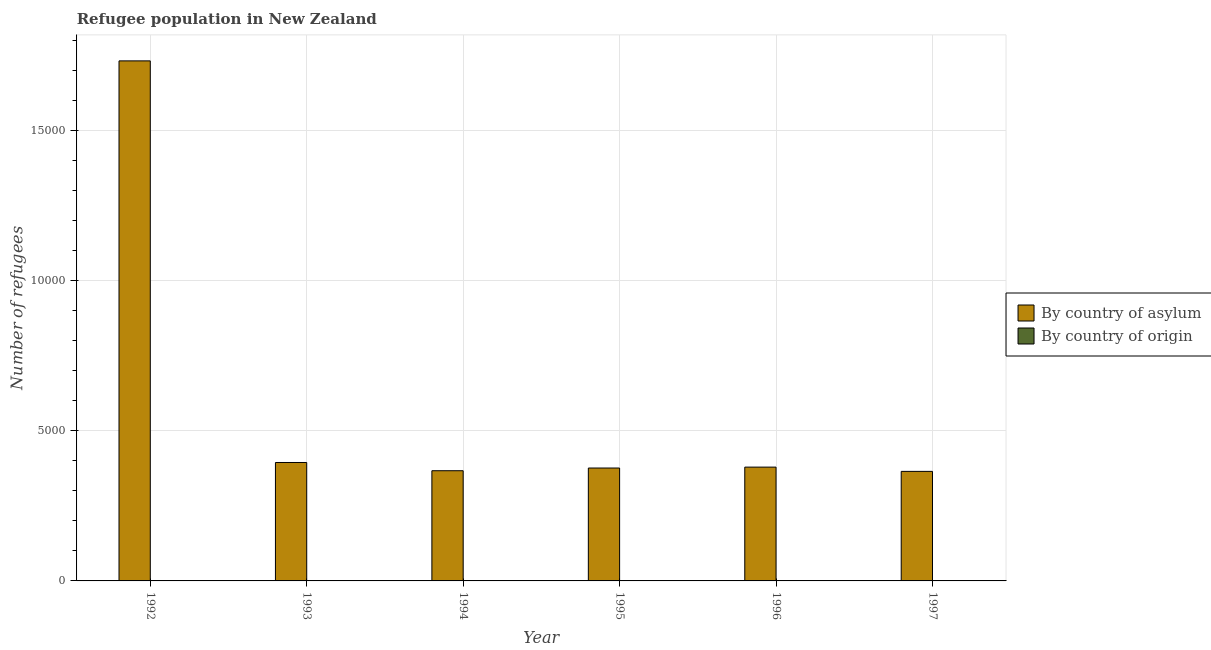How many different coloured bars are there?
Give a very brief answer. 2. How many groups of bars are there?
Your answer should be compact. 6. How many bars are there on the 1st tick from the left?
Keep it short and to the point. 2. What is the label of the 4th group of bars from the left?
Your response must be concise. 1995. In how many cases, is the number of bars for a given year not equal to the number of legend labels?
Offer a terse response. 0. What is the number of refugees by country of asylum in 1997?
Your answer should be very brief. 3646. Across all years, what is the maximum number of refugees by country of asylum?
Your answer should be compact. 1.73e+04. Across all years, what is the minimum number of refugees by country of asylum?
Your answer should be very brief. 3646. In which year was the number of refugees by country of origin maximum?
Your answer should be very brief. 1995. In which year was the number of refugees by country of origin minimum?
Give a very brief answer. 1992. What is the total number of refugees by country of origin in the graph?
Provide a succinct answer. 48. What is the difference between the number of refugees by country of asylum in 1993 and that in 1997?
Keep it short and to the point. 296. What is the difference between the number of refugees by country of origin in 1995 and the number of refugees by country of asylum in 1993?
Offer a terse response. 9. What is the average number of refugees by country of asylum per year?
Ensure brevity in your answer.  6018.67. What is the ratio of the number of refugees by country of asylum in 1992 to that in 1994?
Your answer should be very brief. 4.72. Is the number of refugees by country of origin in 1994 less than that in 1995?
Provide a short and direct response. Yes. What is the difference between the highest and the second highest number of refugees by country of asylum?
Ensure brevity in your answer.  1.34e+04. What is the difference between the highest and the lowest number of refugees by country of asylum?
Ensure brevity in your answer.  1.37e+04. In how many years, is the number of refugees by country of origin greater than the average number of refugees by country of origin taken over all years?
Your answer should be very brief. 3. What does the 1st bar from the left in 1993 represents?
Your answer should be compact. By country of asylum. What does the 1st bar from the right in 1992 represents?
Your response must be concise. By country of origin. Are the values on the major ticks of Y-axis written in scientific E-notation?
Give a very brief answer. No. How many legend labels are there?
Provide a short and direct response. 2. What is the title of the graph?
Offer a very short reply. Refugee population in New Zealand. Does "Education" appear as one of the legend labels in the graph?
Offer a terse response. No. What is the label or title of the Y-axis?
Ensure brevity in your answer.  Number of refugees. What is the Number of refugees of By country of asylum in 1992?
Ensure brevity in your answer.  1.73e+04. What is the Number of refugees of By country of origin in 1992?
Ensure brevity in your answer.  3. What is the Number of refugees of By country of asylum in 1993?
Give a very brief answer. 3942. What is the Number of refugees of By country of origin in 1993?
Provide a succinct answer. 4. What is the Number of refugees of By country of asylum in 1994?
Give a very brief answer. 3668. What is the Number of refugees in By country of origin in 1994?
Your response must be concise. 8. What is the Number of refugees of By country of asylum in 1995?
Make the answer very short. 3758. What is the Number of refugees of By country of origin in 1995?
Your response must be concise. 13. What is the Number of refugees in By country of asylum in 1996?
Give a very brief answer. 3788. What is the Number of refugees of By country of asylum in 1997?
Your answer should be compact. 3646. Across all years, what is the maximum Number of refugees of By country of asylum?
Offer a terse response. 1.73e+04. Across all years, what is the minimum Number of refugees of By country of asylum?
Your answer should be very brief. 3646. Across all years, what is the minimum Number of refugees of By country of origin?
Your response must be concise. 3. What is the total Number of refugees in By country of asylum in the graph?
Give a very brief answer. 3.61e+04. What is the difference between the Number of refugees of By country of asylum in 1992 and that in 1993?
Your answer should be very brief. 1.34e+04. What is the difference between the Number of refugees of By country of asylum in 1992 and that in 1994?
Give a very brief answer. 1.36e+04. What is the difference between the Number of refugees in By country of asylum in 1992 and that in 1995?
Ensure brevity in your answer.  1.36e+04. What is the difference between the Number of refugees of By country of asylum in 1992 and that in 1996?
Your answer should be very brief. 1.35e+04. What is the difference between the Number of refugees in By country of asylum in 1992 and that in 1997?
Your response must be concise. 1.37e+04. What is the difference between the Number of refugees in By country of origin in 1992 and that in 1997?
Provide a short and direct response. -7. What is the difference between the Number of refugees of By country of asylum in 1993 and that in 1994?
Provide a succinct answer. 274. What is the difference between the Number of refugees in By country of origin in 1993 and that in 1994?
Your answer should be compact. -4. What is the difference between the Number of refugees of By country of asylum in 1993 and that in 1995?
Give a very brief answer. 184. What is the difference between the Number of refugees of By country of origin in 1993 and that in 1995?
Provide a succinct answer. -9. What is the difference between the Number of refugees in By country of asylum in 1993 and that in 1996?
Your answer should be compact. 154. What is the difference between the Number of refugees of By country of origin in 1993 and that in 1996?
Provide a short and direct response. -6. What is the difference between the Number of refugees in By country of asylum in 1993 and that in 1997?
Provide a succinct answer. 296. What is the difference between the Number of refugees of By country of origin in 1993 and that in 1997?
Your response must be concise. -6. What is the difference between the Number of refugees in By country of asylum in 1994 and that in 1995?
Provide a short and direct response. -90. What is the difference between the Number of refugees of By country of origin in 1994 and that in 1995?
Your answer should be compact. -5. What is the difference between the Number of refugees of By country of asylum in 1994 and that in 1996?
Your answer should be very brief. -120. What is the difference between the Number of refugees of By country of origin in 1994 and that in 1996?
Your response must be concise. -2. What is the difference between the Number of refugees in By country of origin in 1994 and that in 1997?
Offer a terse response. -2. What is the difference between the Number of refugees in By country of asylum in 1995 and that in 1996?
Ensure brevity in your answer.  -30. What is the difference between the Number of refugees in By country of asylum in 1995 and that in 1997?
Offer a very short reply. 112. What is the difference between the Number of refugees of By country of origin in 1995 and that in 1997?
Keep it short and to the point. 3. What is the difference between the Number of refugees of By country of asylum in 1996 and that in 1997?
Provide a succinct answer. 142. What is the difference between the Number of refugees of By country of asylum in 1992 and the Number of refugees of By country of origin in 1993?
Provide a short and direct response. 1.73e+04. What is the difference between the Number of refugees in By country of asylum in 1992 and the Number of refugees in By country of origin in 1994?
Provide a succinct answer. 1.73e+04. What is the difference between the Number of refugees of By country of asylum in 1992 and the Number of refugees of By country of origin in 1995?
Offer a terse response. 1.73e+04. What is the difference between the Number of refugees in By country of asylum in 1992 and the Number of refugees in By country of origin in 1996?
Make the answer very short. 1.73e+04. What is the difference between the Number of refugees of By country of asylum in 1992 and the Number of refugees of By country of origin in 1997?
Your answer should be very brief. 1.73e+04. What is the difference between the Number of refugees of By country of asylum in 1993 and the Number of refugees of By country of origin in 1994?
Provide a short and direct response. 3934. What is the difference between the Number of refugees of By country of asylum in 1993 and the Number of refugees of By country of origin in 1995?
Provide a short and direct response. 3929. What is the difference between the Number of refugees in By country of asylum in 1993 and the Number of refugees in By country of origin in 1996?
Offer a very short reply. 3932. What is the difference between the Number of refugees in By country of asylum in 1993 and the Number of refugees in By country of origin in 1997?
Ensure brevity in your answer.  3932. What is the difference between the Number of refugees of By country of asylum in 1994 and the Number of refugees of By country of origin in 1995?
Offer a very short reply. 3655. What is the difference between the Number of refugees of By country of asylum in 1994 and the Number of refugees of By country of origin in 1996?
Ensure brevity in your answer.  3658. What is the difference between the Number of refugees in By country of asylum in 1994 and the Number of refugees in By country of origin in 1997?
Provide a short and direct response. 3658. What is the difference between the Number of refugees in By country of asylum in 1995 and the Number of refugees in By country of origin in 1996?
Keep it short and to the point. 3748. What is the difference between the Number of refugees in By country of asylum in 1995 and the Number of refugees in By country of origin in 1997?
Offer a terse response. 3748. What is the difference between the Number of refugees in By country of asylum in 1996 and the Number of refugees in By country of origin in 1997?
Provide a short and direct response. 3778. What is the average Number of refugees of By country of asylum per year?
Keep it short and to the point. 6018.67. What is the average Number of refugees in By country of origin per year?
Offer a terse response. 8. In the year 1992, what is the difference between the Number of refugees in By country of asylum and Number of refugees in By country of origin?
Offer a terse response. 1.73e+04. In the year 1993, what is the difference between the Number of refugees in By country of asylum and Number of refugees in By country of origin?
Provide a succinct answer. 3938. In the year 1994, what is the difference between the Number of refugees in By country of asylum and Number of refugees in By country of origin?
Make the answer very short. 3660. In the year 1995, what is the difference between the Number of refugees in By country of asylum and Number of refugees in By country of origin?
Make the answer very short. 3745. In the year 1996, what is the difference between the Number of refugees in By country of asylum and Number of refugees in By country of origin?
Your answer should be compact. 3778. In the year 1997, what is the difference between the Number of refugees of By country of asylum and Number of refugees of By country of origin?
Give a very brief answer. 3636. What is the ratio of the Number of refugees of By country of asylum in 1992 to that in 1993?
Your answer should be very brief. 4.39. What is the ratio of the Number of refugees of By country of origin in 1992 to that in 1993?
Make the answer very short. 0.75. What is the ratio of the Number of refugees of By country of asylum in 1992 to that in 1994?
Provide a succinct answer. 4.72. What is the ratio of the Number of refugees in By country of origin in 1992 to that in 1994?
Give a very brief answer. 0.38. What is the ratio of the Number of refugees of By country of asylum in 1992 to that in 1995?
Your response must be concise. 4.61. What is the ratio of the Number of refugees of By country of origin in 1992 to that in 1995?
Your response must be concise. 0.23. What is the ratio of the Number of refugees of By country of asylum in 1992 to that in 1996?
Give a very brief answer. 4.57. What is the ratio of the Number of refugees in By country of asylum in 1992 to that in 1997?
Provide a short and direct response. 4.75. What is the ratio of the Number of refugees in By country of asylum in 1993 to that in 1994?
Ensure brevity in your answer.  1.07. What is the ratio of the Number of refugees of By country of origin in 1993 to that in 1994?
Make the answer very short. 0.5. What is the ratio of the Number of refugees in By country of asylum in 1993 to that in 1995?
Keep it short and to the point. 1.05. What is the ratio of the Number of refugees of By country of origin in 1993 to that in 1995?
Make the answer very short. 0.31. What is the ratio of the Number of refugees in By country of asylum in 1993 to that in 1996?
Give a very brief answer. 1.04. What is the ratio of the Number of refugees in By country of origin in 1993 to that in 1996?
Give a very brief answer. 0.4. What is the ratio of the Number of refugees of By country of asylum in 1993 to that in 1997?
Your answer should be compact. 1.08. What is the ratio of the Number of refugees of By country of asylum in 1994 to that in 1995?
Your response must be concise. 0.98. What is the ratio of the Number of refugees in By country of origin in 1994 to that in 1995?
Your response must be concise. 0.62. What is the ratio of the Number of refugees of By country of asylum in 1994 to that in 1996?
Provide a succinct answer. 0.97. What is the ratio of the Number of refugees of By country of origin in 1994 to that in 1996?
Ensure brevity in your answer.  0.8. What is the ratio of the Number of refugees of By country of asylum in 1995 to that in 1996?
Your answer should be compact. 0.99. What is the ratio of the Number of refugees of By country of origin in 1995 to that in 1996?
Your answer should be very brief. 1.3. What is the ratio of the Number of refugees of By country of asylum in 1995 to that in 1997?
Keep it short and to the point. 1.03. What is the ratio of the Number of refugees of By country of asylum in 1996 to that in 1997?
Provide a short and direct response. 1.04. What is the difference between the highest and the second highest Number of refugees in By country of asylum?
Offer a very short reply. 1.34e+04. What is the difference between the highest and the second highest Number of refugees in By country of origin?
Your answer should be compact. 3. What is the difference between the highest and the lowest Number of refugees of By country of asylum?
Give a very brief answer. 1.37e+04. 